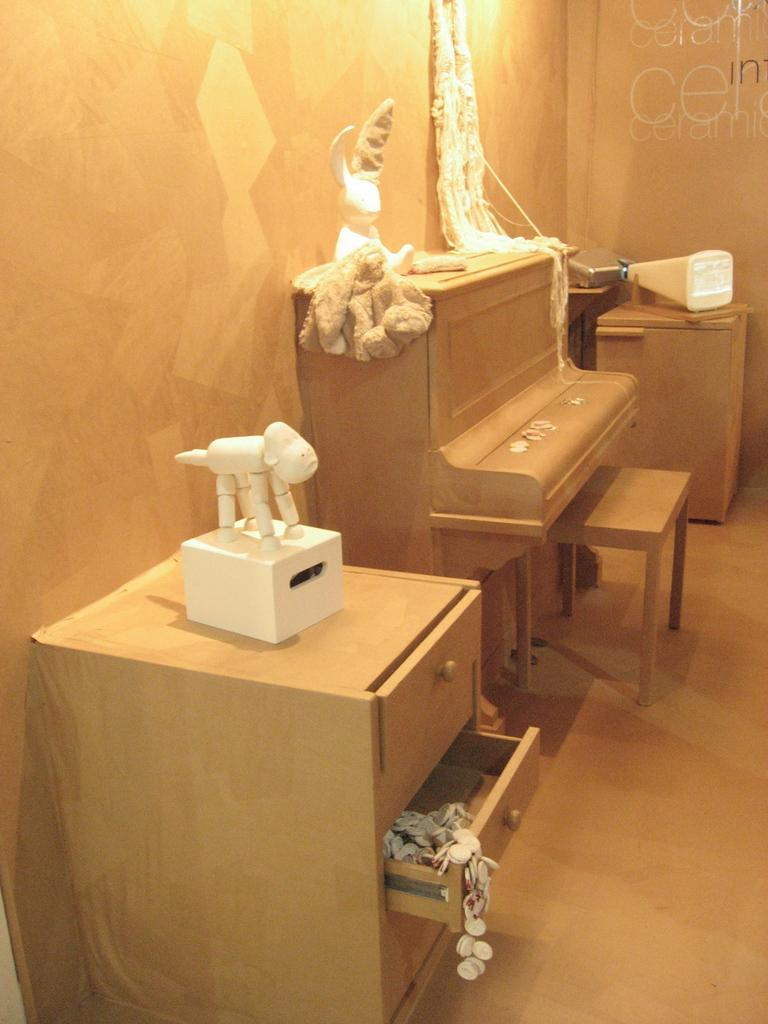What type of space is depicted in the image? There is a room in the image. What type of furniture is present in the room? There are cabinets in the room. What object is used for playing music in the room? There is a keyboard in the room. What type of items are meant for children's entertainment in the room? There are toys in the room. What can be seen on the walls of the room? The wall is visible in the room. How many snakes are slithering on the keyboard in the image? There are no snakes present in the image, and therefore no snakes can be seen on the keyboard. 